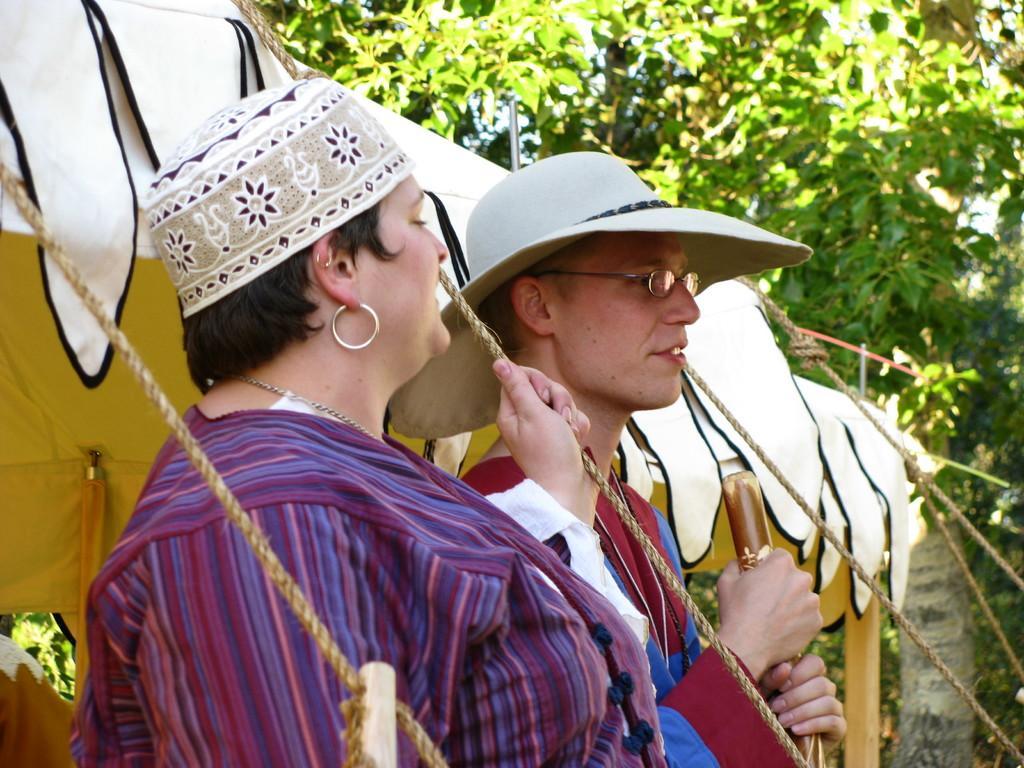How would you summarize this image in a sentence or two? In the image there are two persons standing with a cap and hat on their head. There is a man with spectacles. Behind them there is a tent with ropes. And in the background there are trees. 